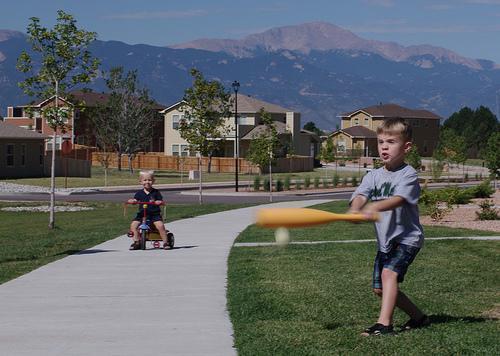How many children are shown?
Give a very brief answer. 2. 